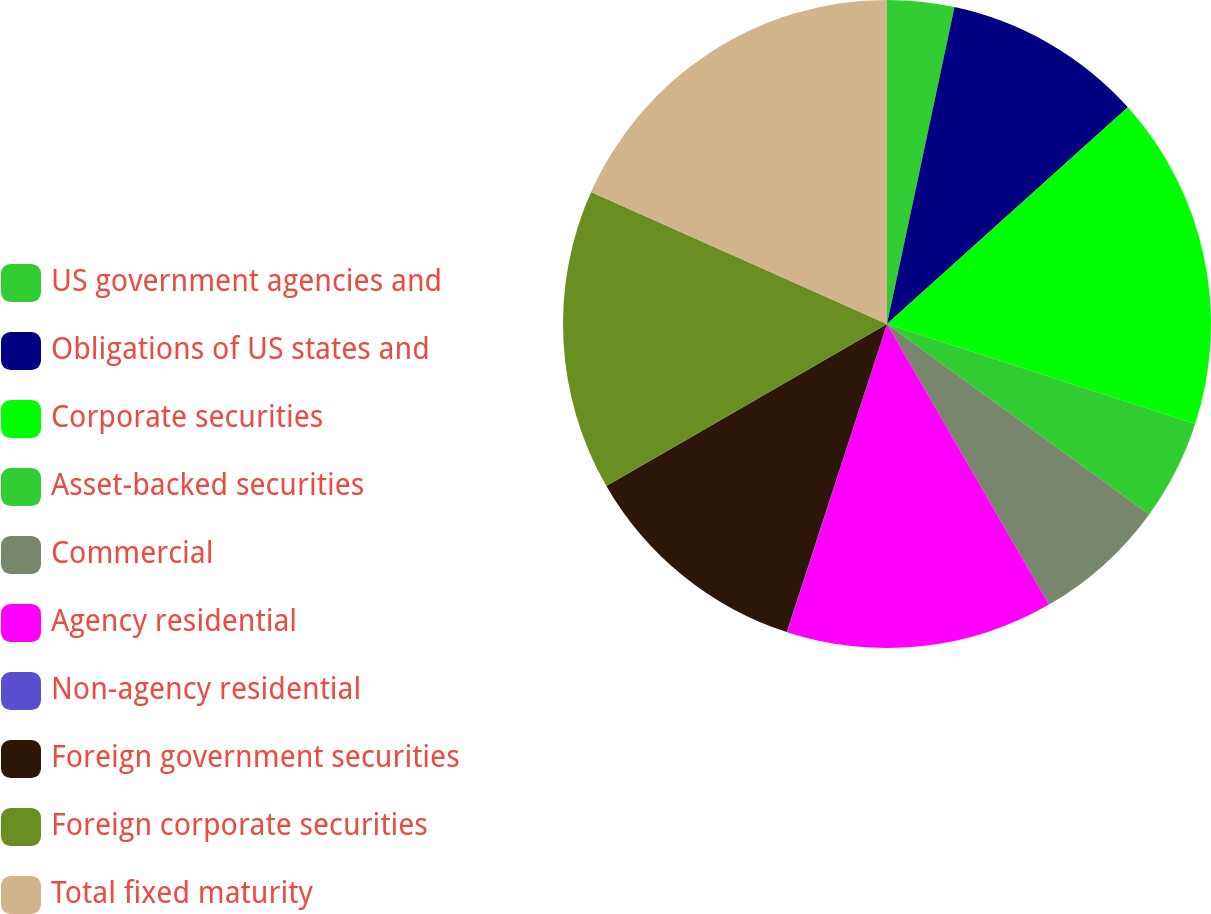<chart> <loc_0><loc_0><loc_500><loc_500><pie_chart><fcel>US government agencies and<fcel>Obligations of US states and<fcel>Corporate securities<fcel>Asset-backed securities<fcel>Commercial<fcel>Agency residential<fcel>Non-agency residential<fcel>Foreign government securities<fcel>Foreign corporate securities<fcel>Total fixed maturity<nl><fcel>3.34%<fcel>10.0%<fcel>16.66%<fcel>5.0%<fcel>6.67%<fcel>13.33%<fcel>0.01%<fcel>11.67%<fcel>15.0%<fcel>18.33%<nl></chart> 